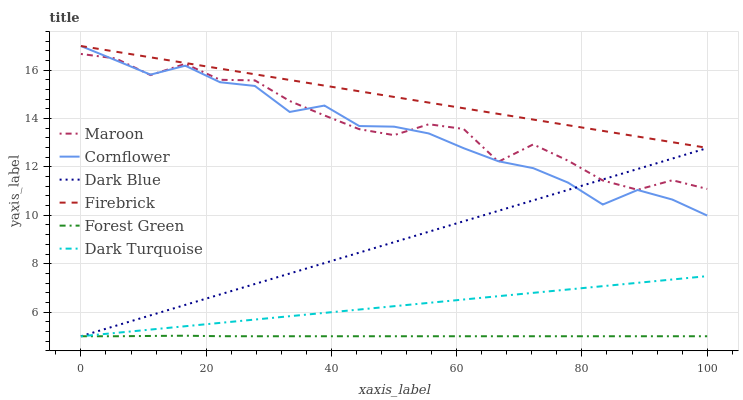Does Forest Green have the minimum area under the curve?
Answer yes or no. Yes. Does Firebrick have the maximum area under the curve?
Answer yes or no. Yes. Does Dark Turquoise have the minimum area under the curve?
Answer yes or no. No. Does Dark Turquoise have the maximum area under the curve?
Answer yes or no. No. Is Dark Turquoise the smoothest?
Answer yes or no. Yes. Is Maroon the roughest?
Answer yes or no. Yes. Is Firebrick the smoothest?
Answer yes or no. No. Is Firebrick the roughest?
Answer yes or no. No. Does Dark Turquoise have the lowest value?
Answer yes or no. Yes. Does Firebrick have the lowest value?
Answer yes or no. No. Does Firebrick have the highest value?
Answer yes or no. Yes. Does Dark Turquoise have the highest value?
Answer yes or no. No. Is Forest Green less than Maroon?
Answer yes or no. Yes. Is Firebrick greater than Dark Blue?
Answer yes or no. Yes. Does Dark Turquoise intersect Dark Blue?
Answer yes or no. Yes. Is Dark Turquoise less than Dark Blue?
Answer yes or no. No. Is Dark Turquoise greater than Dark Blue?
Answer yes or no. No. Does Forest Green intersect Maroon?
Answer yes or no. No. 